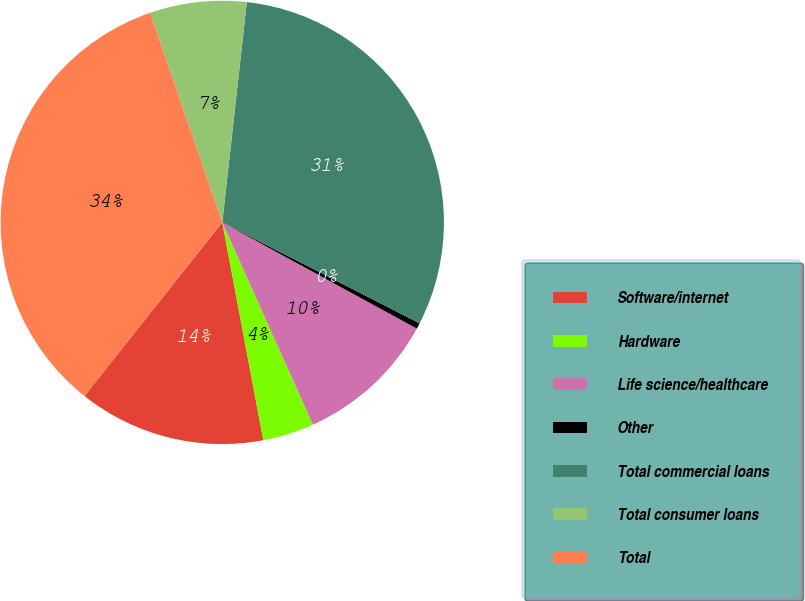Convert chart to OTSL. <chart><loc_0><loc_0><loc_500><loc_500><pie_chart><fcel>Software/internet<fcel>Hardware<fcel>Life science/healthcare<fcel>Other<fcel>Total commercial loans<fcel>Total consumer loans<fcel>Total<nl><fcel>13.64%<fcel>3.74%<fcel>10.34%<fcel>0.43%<fcel>30.75%<fcel>7.04%<fcel>34.05%<nl></chart> 